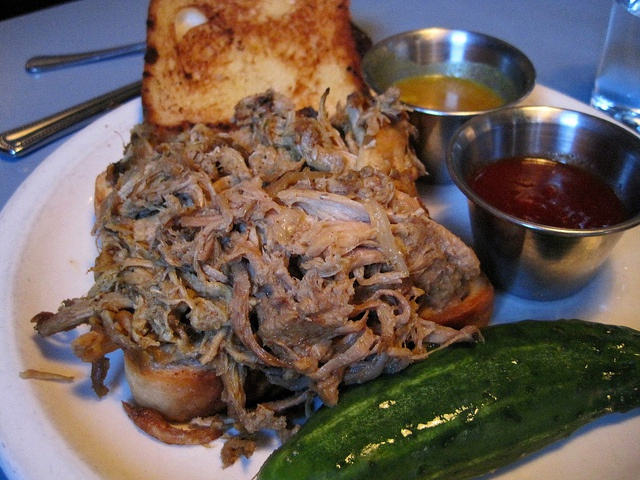Describe the objects in this image and their specific colors. I can see sandwich in black, gray, brown, and maroon tones, bowl in black, maroon, gray, and navy tones, bowl in black, gray, and olive tones, cup in black, gray, and blue tones, and spoon in black and gray tones in this image. 